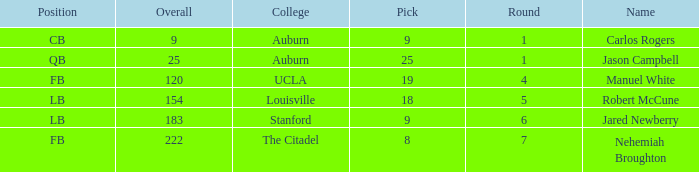Which college had an overall pick of 9? Auburn. Would you mind parsing the complete table? {'header': ['Position', 'Overall', 'College', 'Pick', 'Round', 'Name'], 'rows': [['CB', '9', 'Auburn', '9', '1', 'Carlos Rogers'], ['QB', '25', 'Auburn', '25', '1', 'Jason Campbell'], ['FB', '120', 'UCLA', '19', '4', 'Manuel White'], ['LB', '154', 'Louisville', '18', '5', 'Robert McCune'], ['LB', '183', 'Stanford', '9', '6', 'Jared Newberry'], ['FB', '222', 'The Citadel', '8', '7', 'Nehemiah Broughton']]} 